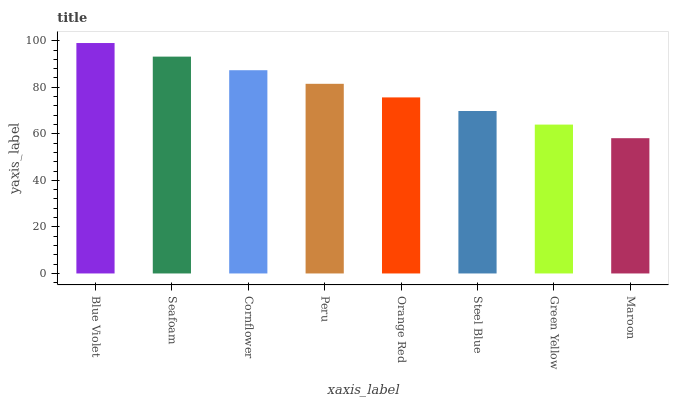Is Seafoam the minimum?
Answer yes or no. No. Is Seafoam the maximum?
Answer yes or no. No. Is Blue Violet greater than Seafoam?
Answer yes or no. Yes. Is Seafoam less than Blue Violet?
Answer yes or no. Yes. Is Seafoam greater than Blue Violet?
Answer yes or no. No. Is Blue Violet less than Seafoam?
Answer yes or no. No. Is Peru the high median?
Answer yes or no. Yes. Is Orange Red the low median?
Answer yes or no. Yes. Is Steel Blue the high median?
Answer yes or no. No. Is Blue Violet the low median?
Answer yes or no. No. 